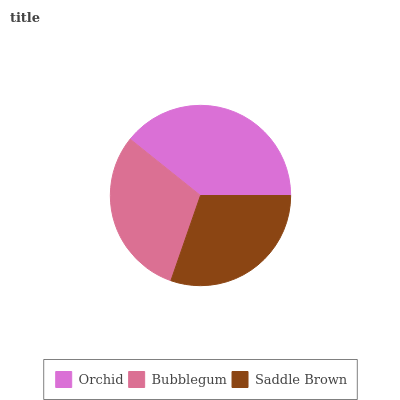Is Saddle Brown the minimum?
Answer yes or no. Yes. Is Orchid the maximum?
Answer yes or no. Yes. Is Bubblegum the minimum?
Answer yes or no. No. Is Bubblegum the maximum?
Answer yes or no. No. Is Orchid greater than Bubblegum?
Answer yes or no. Yes. Is Bubblegum less than Orchid?
Answer yes or no. Yes. Is Bubblegum greater than Orchid?
Answer yes or no. No. Is Orchid less than Bubblegum?
Answer yes or no. No. Is Bubblegum the high median?
Answer yes or no. Yes. Is Bubblegum the low median?
Answer yes or no. Yes. Is Orchid the high median?
Answer yes or no. No. Is Orchid the low median?
Answer yes or no. No. 